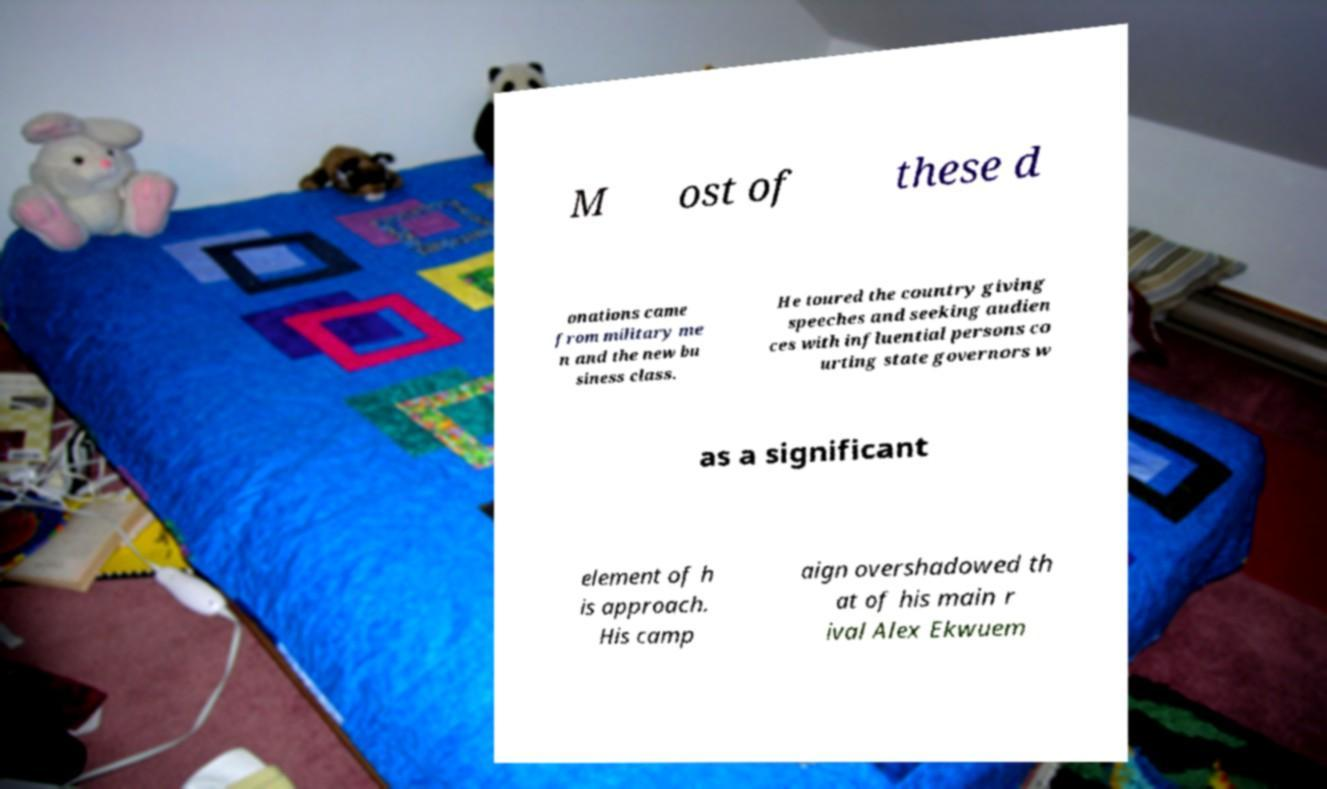I need the written content from this picture converted into text. Can you do that? M ost of these d onations came from military me n and the new bu siness class. He toured the country giving speeches and seeking audien ces with influential persons co urting state governors w as a significant element of h is approach. His camp aign overshadowed th at of his main r ival Alex Ekwuem 